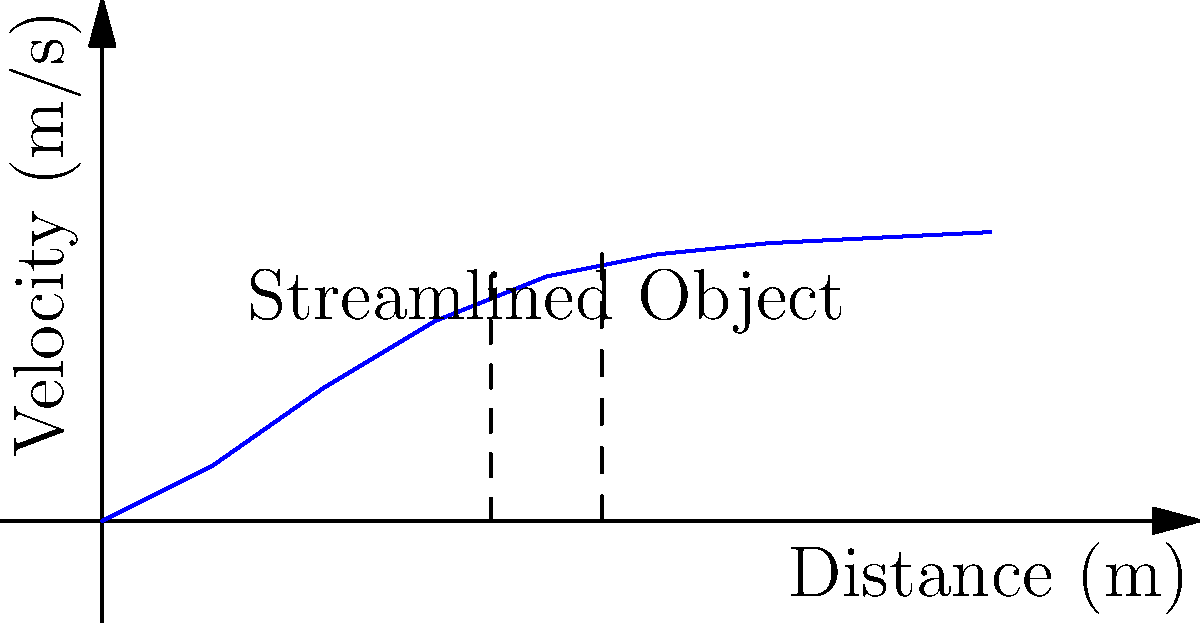In the graph above, which represents the velocity profile of air flowing around a streamlined object, at what approximate distance from the leading edge does the air velocity reach its maximum? To determine the distance at which the air velocity reaches its maximum, we need to analyze the graph step-by-step:

1. The x-axis represents the distance from the leading edge of the streamlined object in meters.
2. The y-axis represents the velocity of the air in m/s.
3. The curve shows how the air velocity changes as it moves past the object.
4. We can see that the velocity increases rapidly at first, then slows its increase, and finally plateaus.
5. The maximum velocity is reached when the curve stops increasing and becomes nearly horizontal.
6. By examining the graph, we can see that this occurs at approximately 7 meters from the leading edge.
7. After this point, the velocity increase is negligible, indicating we've reached the maximum.

The question asks for an approximate distance, so we don't need to be more precise than the nearest whole number.
Answer: 7 meters 